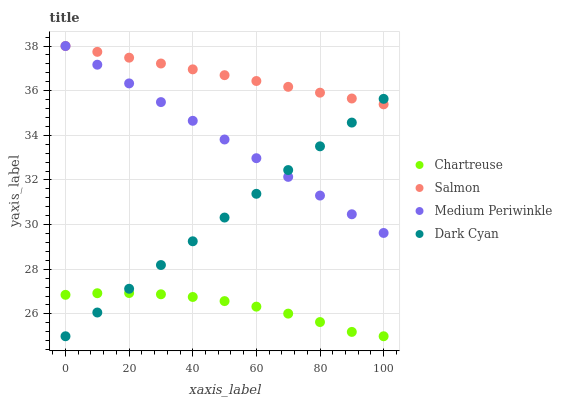Does Chartreuse have the minimum area under the curve?
Answer yes or no. Yes. Does Salmon have the maximum area under the curve?
Answer yes or no. Yes. Does Medium Periwinkle have the minimum area under the curve?
Answer yes or no. No. Does Medium Periwinkle have the maximum area under the curve?
Answer yes or no. No. Is Salmon the smoothest?
Answer yes or no. Yes. Is Chartreuse the roughest?
Answer yes or no. Yes. Is Medium Periwinkle the smoothest?
Answer yes or no. No. Is Medium Periwinkle the roughest?
Answer yes or no. No. Does Dark Cyan have the lowest value?
Answer yes or no. Yes. Does Medium Periwinkle have the lowest value?
Answer yes or no. No. Does Salmon have the highest value?
Answer yes or no. Yes. Does Chartreuse have the highest value?
Answer yes or no. No. Is Chartreuse less than Salmon?
Answer yes or no. Yes. Is Salmon greater than Chartreuse?
Answer yes or no. Yes. Does Salmon intersect Dark Cyan?
Answer yes or no. Yes. Is Salmon less than Dark Cyan?
Answer yes or no. No. Is Salmon greater than Dark Cyan?
Answer yes or no. No. Does Chartreuse intersect Salmon?
Answer yes or no. No. 